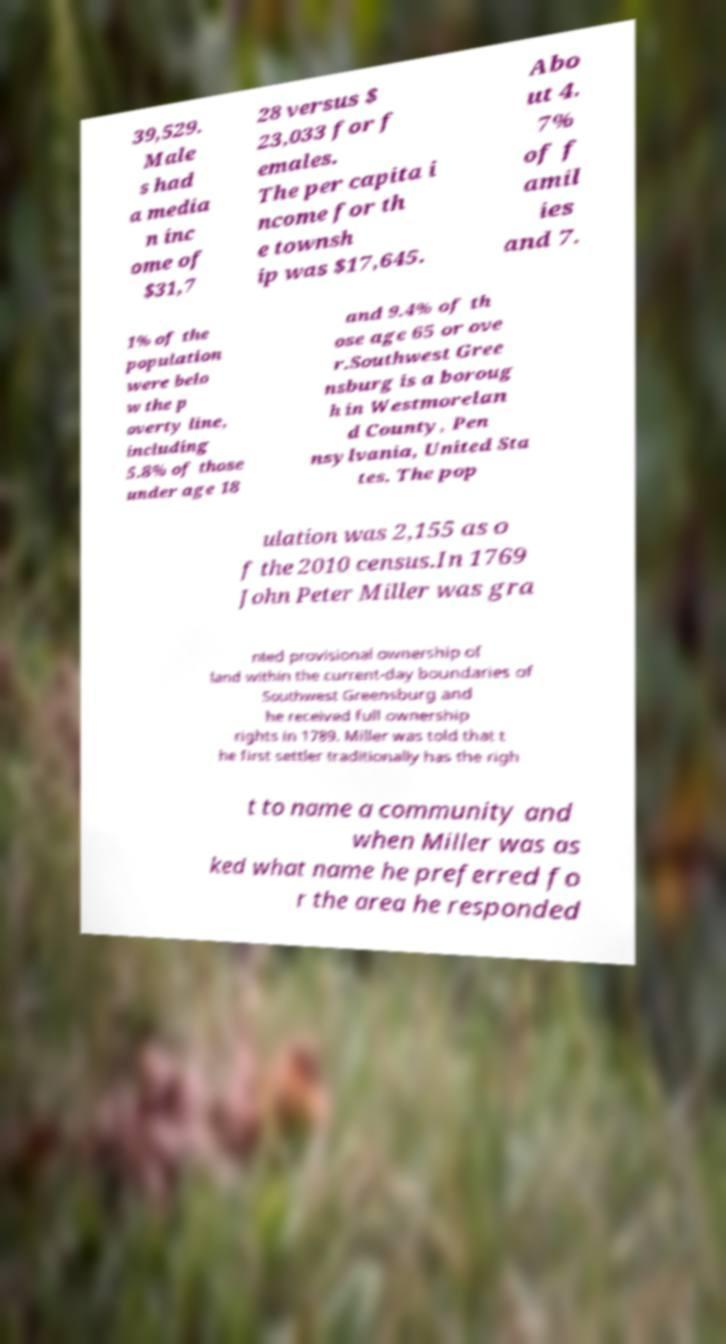Can you read and provide the text displayed in the image?This photo seems to have some interesting text. Can you extract and type it out for me? 39,529. Male s had a media n inc ome of $31,7 28 versus $ 23,033 for f emales. The per capita i ncome for th e townsh ip was $17,645. Abo ut 4. 7% of f amil ies and 7. 1% of the population were belo w the p overty line, including 5.8% of those under age 18 and 9.4% of th ose age 65 or ove r.Southwest Gree nsburg is a boroug h in Westmorelan d County, Pen nsylvania, United Sta tes. The pop ulation was 2,155 as o f the 2010 census.In 1769 John Peter Miller was gra nted provisional ownership of land within the current-day boundaries of Southwest Greensburg and he received full ownership rights in 1789. Miller was told that t he first settler traditionally has the righ t to name a community and when Miller was as ked what name he preferred fo r the area he responded 